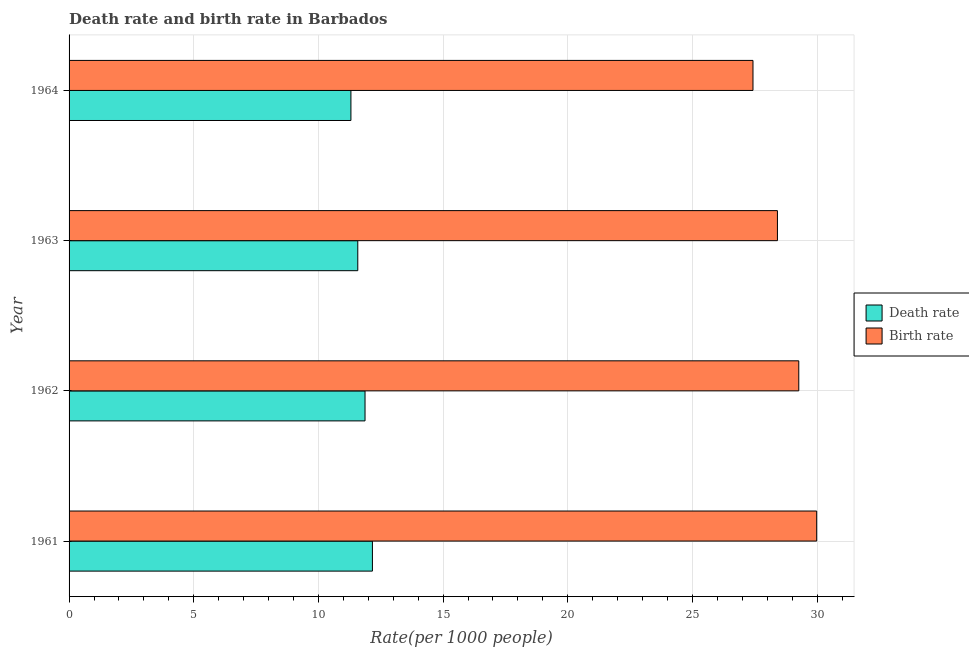How many groups of bars are there?
Your answer should be compact. 4. Are the number of bars per tick equal to the number of legend labels?
Make the answer very short. Yes. Are the number of bars on each tick of the Y-axis equal?
Provide a succinct answer. Yes. How many bars are there on the 3rd tick from the top?
Give a very brief answer. 2. How many bars are there on the 1st tick from the bottom?
Ensure brevity in your answer.  2. What is the label of the 1st group of bars from the top?
Ensure brevity in your answer.  1964. In how many cases, is the number of bars for a given year not equal to the number of legend labels?
Keep it short and to the point. 0. What is the birth rate in 1961?
Your response must be concise. 29.98. Across all years, what is the maximum birth rate?
Offer a very short reply. 29.98. Across all years, what is the minimum death rate?
Your response must be concise. 11.3. In which year was the death rate maximum?
Your answer should be very brief. 1961. In which year was the death rate minimum?
Give a very brief answer. 1964. What is the total death rate in the graph?
Provide a short and direct response. 46.92. What is the difference between the birth rate in 1961 and that in 1962?
Your response must be concise. 0.72. What is the difference between the death rate in 1962 and the birth rate in 1961?
Your response must be concise. -18.11. What is the average birth rate per year?
Offer a very short reply. 28.77. In the year 1964, what is the difference between the birth rate and death rate?
Ensure brevity in your answer.  16.12. In how many years, is the birth rate greater than 5 ?
Keep it short and to the point. 4. What is the ratio of the death rate in 1962 to that in 1963?
Your answer should be compact. 1.02. Is the difference between the death rate in 1962 and 1963 greater than the difference between the birth rate in 1962 and 1963?
Keep it short and to the point. No. What is the difference between the highest and the second highest death rate?
Keep it short and to the point. 0.3. What is the difference between the highest and the lowest birth rate?
Keep it short and to the point. 2.56. In how many years, is the birth rate greater than the average birth rate taken over all years?
Provide a short and direct response. 2. Is the sum of the birth rate in 1961 and 1962 greater than the maximum death rate across all years?
Make the answer very short. Yes. What does the 1st bar from the top in 1964 represents?
Ensure brevity in your answer.  Birth rate. What does the 1st bar from the bottom in 1963 represents?
Your response must be concise. Death rate. How many bars are there?
Keep it short and to the point. 8. How many years are there in the graph?
Your answer should be very brief. 4. What is the difference between two consecutive major ticks on the X-axis?
Provide a succinct answer. 5. Are the values on the major ticks of X-axis written in scientific E-notation?
Provide a short and direct response. No. Does the graph contain any zero values?
Give a very brief answer. No. Where does the legend appear in the graph?
Offer a very short reply. Center right. What is the title of the graph?
Your answer should be very brief. Death rate and birth rate in Barbados. Does "Underweight" appear as one of the legend labels in the graph?
Your answer should be very brief. No. What is the label or title of the X-axis?
Make the answer very short. Rate(per 1000 people). What is the Rate(per 1000 people) in Death rate in 1961?
Provide a short and direct response. 12.17. What is the Rate(per 1000 people) of Birth rate in 1961?
Ensure brevity in your answer.  29.98. What is the Rate(per 1000 people) in Death rate in 1962?
Offer a very short reply. 11.87. What is the Rate(per 1000 people) in Birth rate in 1962?
Ensure brevity in your answer.  29.27. What is the Rate(per 1000 people) of Death rate in 1963?
Offer a very short reply. 11.58. What is the Rate(per 1000 people) of Birth rate in 1963?
Offer a very short reply. 28.41. What is the Rate(per 1000 people) of Death rate in 1964?
Your answer should be very brief. 11.3. What is the Rate(per 1000 people) in Birth rate in 1964?
Provide a succinct answer. 27.43. Across all years, what is the maximum Rate(per 1000 people) of Death rate?
Keep it short and to the point. 12.17. Across all years, what is the maximum Rate(per 1000 people) in Birth rate?
Give a very brief answer. 29.98. Across all years, what is the minimum Rate(per 1000 people) of Death rate?
Offer a very short reply. 11.3. Across all years, what is the minimum Rate(per 1000 people) in Birth rate?
Ensure brevity in your answer.  27.43. What is the total Rate(per 1000 people) of Death rate in the graph?
Keep it short and to the point. 46.92. What is the total Rate(per 1000 people) in Birth rate in the graph?
Keep it short and to the point. 115.09. What is the difference between the Rate(per 1000 people) of Death rate in 1961 and that in 1962?
Your answer should be very brief. 0.3. What is the difference between the Rate(per 1000 people) of Birth rate in 1961 and that in 1962?
Your answer should be very brief. 0.72. What is the difference between the Rate(per 1000 people) in Death rate in 1961 and that in 1963?
Offer a terse response. 0.59. What is the difference between the Rate(per 1000 people) in Birth rate in 1961 and that in 1963?
Your answer should be very brief. 1.57. What is the difference between the Rate(per 1000 people) in Death rate in 1961 and that in 1964?
Offer a terse response. 0.86. What is the difference between the Rate(per 1000 people) in Birth rate in 1961 and that in 1964?
Your response must be concise. 2.56. What is the difference between the Rate(per 1000 people) of Death rate in 1962 and that in 1963?
Make the answer very short. 0.29. What is the difference between the Rate(per 1000 people) of Birth rate in 1962 and that in 1963?
Offer a terse response. 0.86. What is the difference between the Rate(per 1000 people) in Death rate in 1962 and that in 1964?
Offer a terse response. 0.57. What is the difference between the Rate(per 1000 people) of Birth rate in 1962 and that in 1964?
Make the answer very short. 1.84. What is the difference between the Rate(per 1000 people) of Death rate in 1963 and that in 1964?
Make the answer very short. 0.28. What is the difference between the Rate(per 1000 people) of Birth rate in 1963 and that in 1964?
Your response must be concise. 0.98. What is the difference between the Rate(per 1000 people) in Death rate in 1961 and the Rate(per 1000 people) in Birth rate in 1962?
Make the answer very short. -17.1. What is the difference between the Rate(per 1000 people) in Death rate in 1961 and the Rate(per 1000 people) in Birth rate in 1963?
Your response must be concise. -16.24. What is the difference between the Rate(per 1000 people) in Death rate in 1961 and the Rate(per 1000 people) in Birth rate in 1964?
Give a very brief answer. -15.26. What is the difference between the Rate(per 1000 people) of Death rate in 1962 and the Rate(per 1000 people) of Birth rate in 1963?
Offer a very short reply. -16.54. What is the difference between the Rate(per 1000 people) in Death rate in 1962 and the Rate(per 1000 people) in Birth rate in 1964?
Give a very brief answer. -15.56. What is the difference between the Rate(per 1000 people) of Death rate in 1963 and the Rate(per 1000 people) of Birth rate in 1964?
Offer a terse response. -15.85. What is the average Rate(per 1000 people) in Death rate per year?
Provide a succinct answer. 11.73. What is the average Rate(per 1000 people) of Birth rate per year?
Offer a terse response. 28.77. In the year 1961, what is the difference between the Rate(per 1000 people) in Death rate and Rate(per 1000 people) in Birth rate?
Offer a terse response. -17.82. In the year 1962, what is the difference between the Rate(per 1000 people) in Death rate and Rate(per 1000 people) in Birth rate?
Provide a succinct answer. -17.4. In the year 1963, what is the difference between the Rate(per 1000 people) of Death rate and Rate(per 1000 people) of Birth rate?
Keep it short and to the point. -16.83. In the year 1964, what is the difference between the Rate(per 1000 people) of Death rate and Rate(per 1000 people) of Birth rate?
Make the answer very short. -16.12. What is the ratio of the Rate(per 1000 people) of Death rate in 1961 to that in 1962?
Provide a succinct answer. 1.02. What is the ratio of the Rate(per 1000 people) of Birth rate in 1961 to that in 1962?
Offer a terse response. 1.02. What is the ratio of the Rate(per 1000 people) of Death rate in 1961 to that in 1963?
Ensure brevity in your answer.  1.05. What is the ratio of the Rate(per 1000 people) of Birth rate in 1961 to that in 1963?
Provide a succinct answer. 1.06. What is the ratio of the Rate(per 1000 people) in Death rate in 1961 to that in 1964?
Keep it short and to the point. 1.08. What is the ratio of the Rate(per 1000 people) in Birth rate in 1961 to that in 1964?
Keep it short and to the point. 1.09. What is the ratio of the Rate(per 1000 people) of Death rate in 1962 to that in 1963?
Your answer should be compact. 1.03. What is the ratio of the Rate(per 1000 people) in Birth rate in 1962 to that in 1963?
Your answer should be very brief. 1.03. What is the ratio of the Rate(per 1000 people) in Death rate in 1962 to that in 1964?
Make the answer very short. 1.05. What is the ratio of the Rate(per 1000 people) in Birth rate in 1962 to that in 1964?
Give a very brief answer. 1.07. What is the ratio of the Rate(per 1000 people) in Death rate in 1963 to that in 1964?
Ensure brevity in your answer.  1.02. What is the ratio of the Rate(per 1000 people) in Birth rate in 1963 to that in 1964?
Your response must be concise. 1.04. What is the difference between the highest and the second highest Rate(per 1000 people) of Death rate?
Your response must be concise. 0.3. What is the difference between the highest and the second highest Rate(per 1000 people) of Birth rate?
Your answer should be compact. 0.72. What is the difference between the highest and the lowest Rate(per 1000 people) of Death rate?
Your answer should be very brief. 0.86. What is the difference between the highest and the lowest Rate(per 1000 people) of Birth rate?
Give a very brief answer. 2.56. 